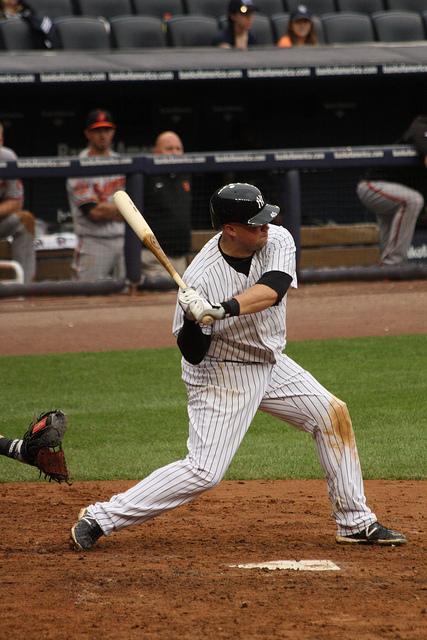Are the player's pants dirty?
Short answer required. Yes. Why are his pants dirty?
Quick response, please. Slid in dirt. What type of game is this?
Answer briefly. Baseball. What is in the player's hand?
Quick response, please. Bat. 